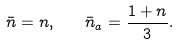Convert formula to latex. <formula><loc_0><loc_0><loc_500><loc_500>\bar { n } = n , \quad \bar { n } _ { a } = \frac { 1 + n } { 3 } .</formula> 